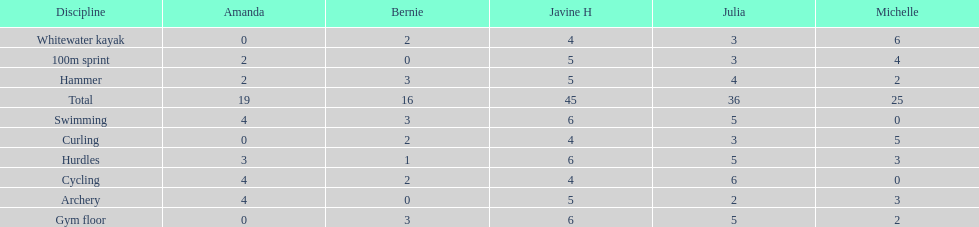Who had her best score in cycling? Julia. 